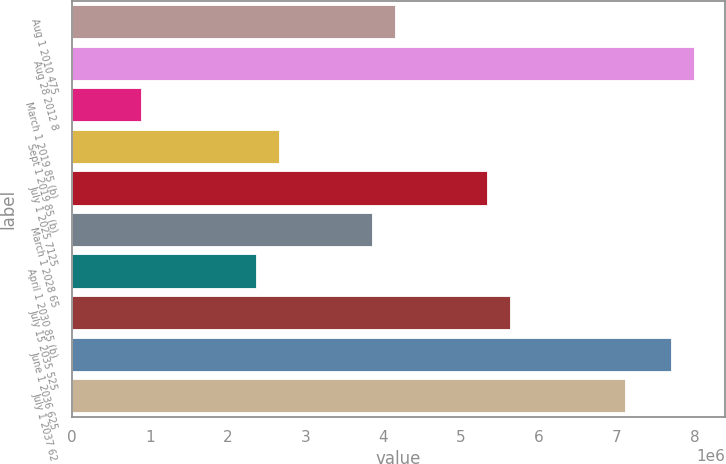Convert chart to OTSL. <chart><loc_0><loc_0><loc_500><loc_500><bar_chart><fcel>Aug 1 2010 475<fcel>Aug 28 2012 8<fcel>March 1 2019 85 (b)<fcel>Sept 1 2019 85 (b)<fcel>July 1 2025 7125<fcel>March 1 2028 65<fcel>April 1 2030 85 (b)<fcel>July 15 2035 525<fcel>June 1 2036 625<fcel>July 1 2037 62<nl><fcel>4.14781e+06<fcel>7.99924e+06<fcel>888900<fcel>2.66648e+06<fcel>5.33286e+06<fcel>3.85154e+06<fcel>2.37022e+06<fcel>5.62913e+06<fcel>7.70298e+06<fcel>7.11045e+06<nl></chart> 